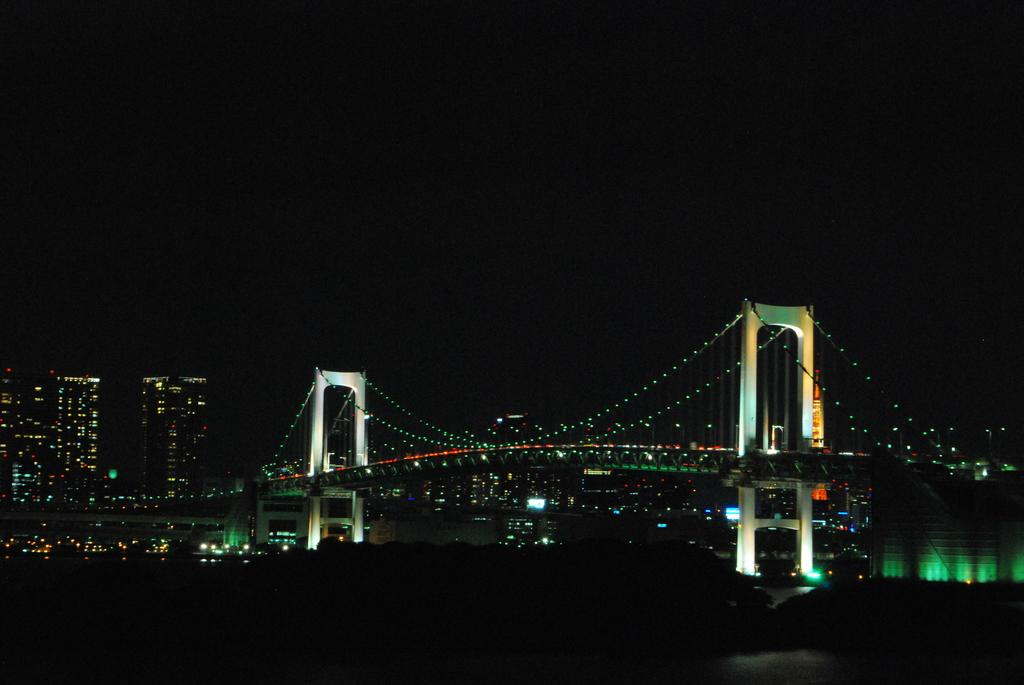What structure is the main subject of the image? There is a bridge in the image. What feature does the bridge have? The bridge has lights. What can be seen in the background of the image? There is a group of buildings and the sky visible in the background of the image. What type of pets can be seen playing near the bridge in the image? There are no pets visible in the image; it only features a bridge with lights and a background with buildings and the sky. 